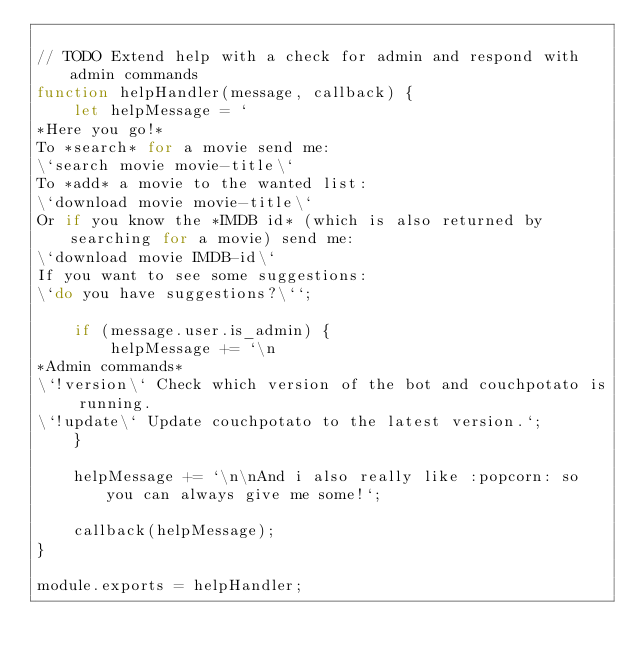Convert code to text. <code><loc_0><loc_0><loc_500><loc_500><_JavaScript_>
// TODO Extend help with a check for admin and respond with admin commands
function helpHandler(message, callback) {
	let helpMessage = `
*Here you go!*
To *search* for a movie send me:
\`search movie movie-title\`
To *add* a movie to the wanted list:
\`download movie movie-title\`
Or if you know the *IMDB id* (which is also returned by searching for a movie) send me:
\`download movie IMDB-id\`
If you want to see some suggestions:
\`do you have suggestions?\``;

	if (message.user.is_admin) {
		helpMessage += `\n
*Admin commands*
\`!version\` Check which version of the bot and couchpotato is running.
\`!update\` Update couchpotato to the latest version.`;
	}

	helpMessage += `\n\nAnd i also really like :popcorn: so you can always give me some!`;

	callback(helpMessage);
}

module.exports = helpHandler;
</code> 